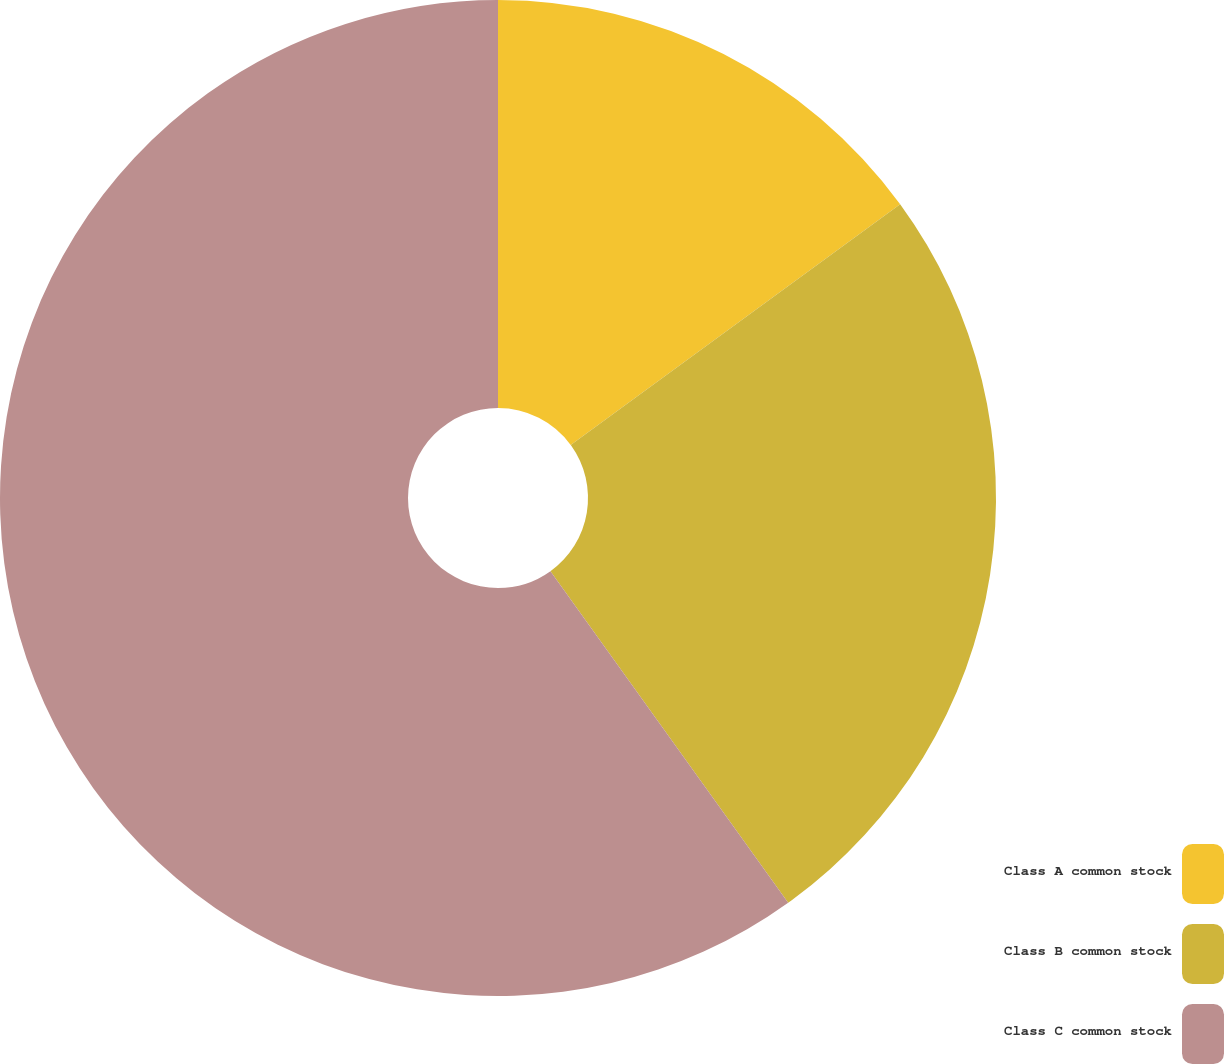Convert chart to OTSL. <chart><loc_0><loc_0><loc_500><loc_500><pie_chart><fcel>Class A common stock<fcel>Class B common stock<fcel>Class C common stock<nl><fcel>14.96%<fcel>25.14%<fcel>59.9%<nl></chart> 